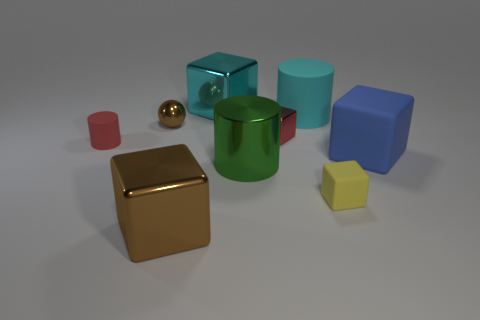Do the small matte cylinder and the small metal cube have the same color?
Make the answer very short. Yes. There is a large cube that is both in front of the brown shiny sphere and to the left of the yellow object; what material is it?
Your answer should be very brief. Metal. Does the tiny cylinder have the same material as the tiny brown thing?
Provide a short and direct response. No. There is a metallic block that is in front of the cyan matte cylinder and behind the tiny yellow object; what size is it?
Provide a succinct answer. Small. The big green thing is what shape?
Your response must be concise. Cylinder. What number of things are either big green objects or things that are to the right of the shiny ball?
Provide a succinct answer. 7. Do the small rubber object that is to the left of the metallic cylinder and the small metal block have the same color?
Offer a terse response. Yes. What is the color of the tiny thing that is both to the left of the big brown metal thing and behind the tiny rubber cylinder?
Ensure brevity in your answer.  Brown. There is a tiny block in front of the big green metallic cylinder; what is its material?
Provide a short and direct response. Rubber. How big is the brown ball?
Offer a terse response. Small. 